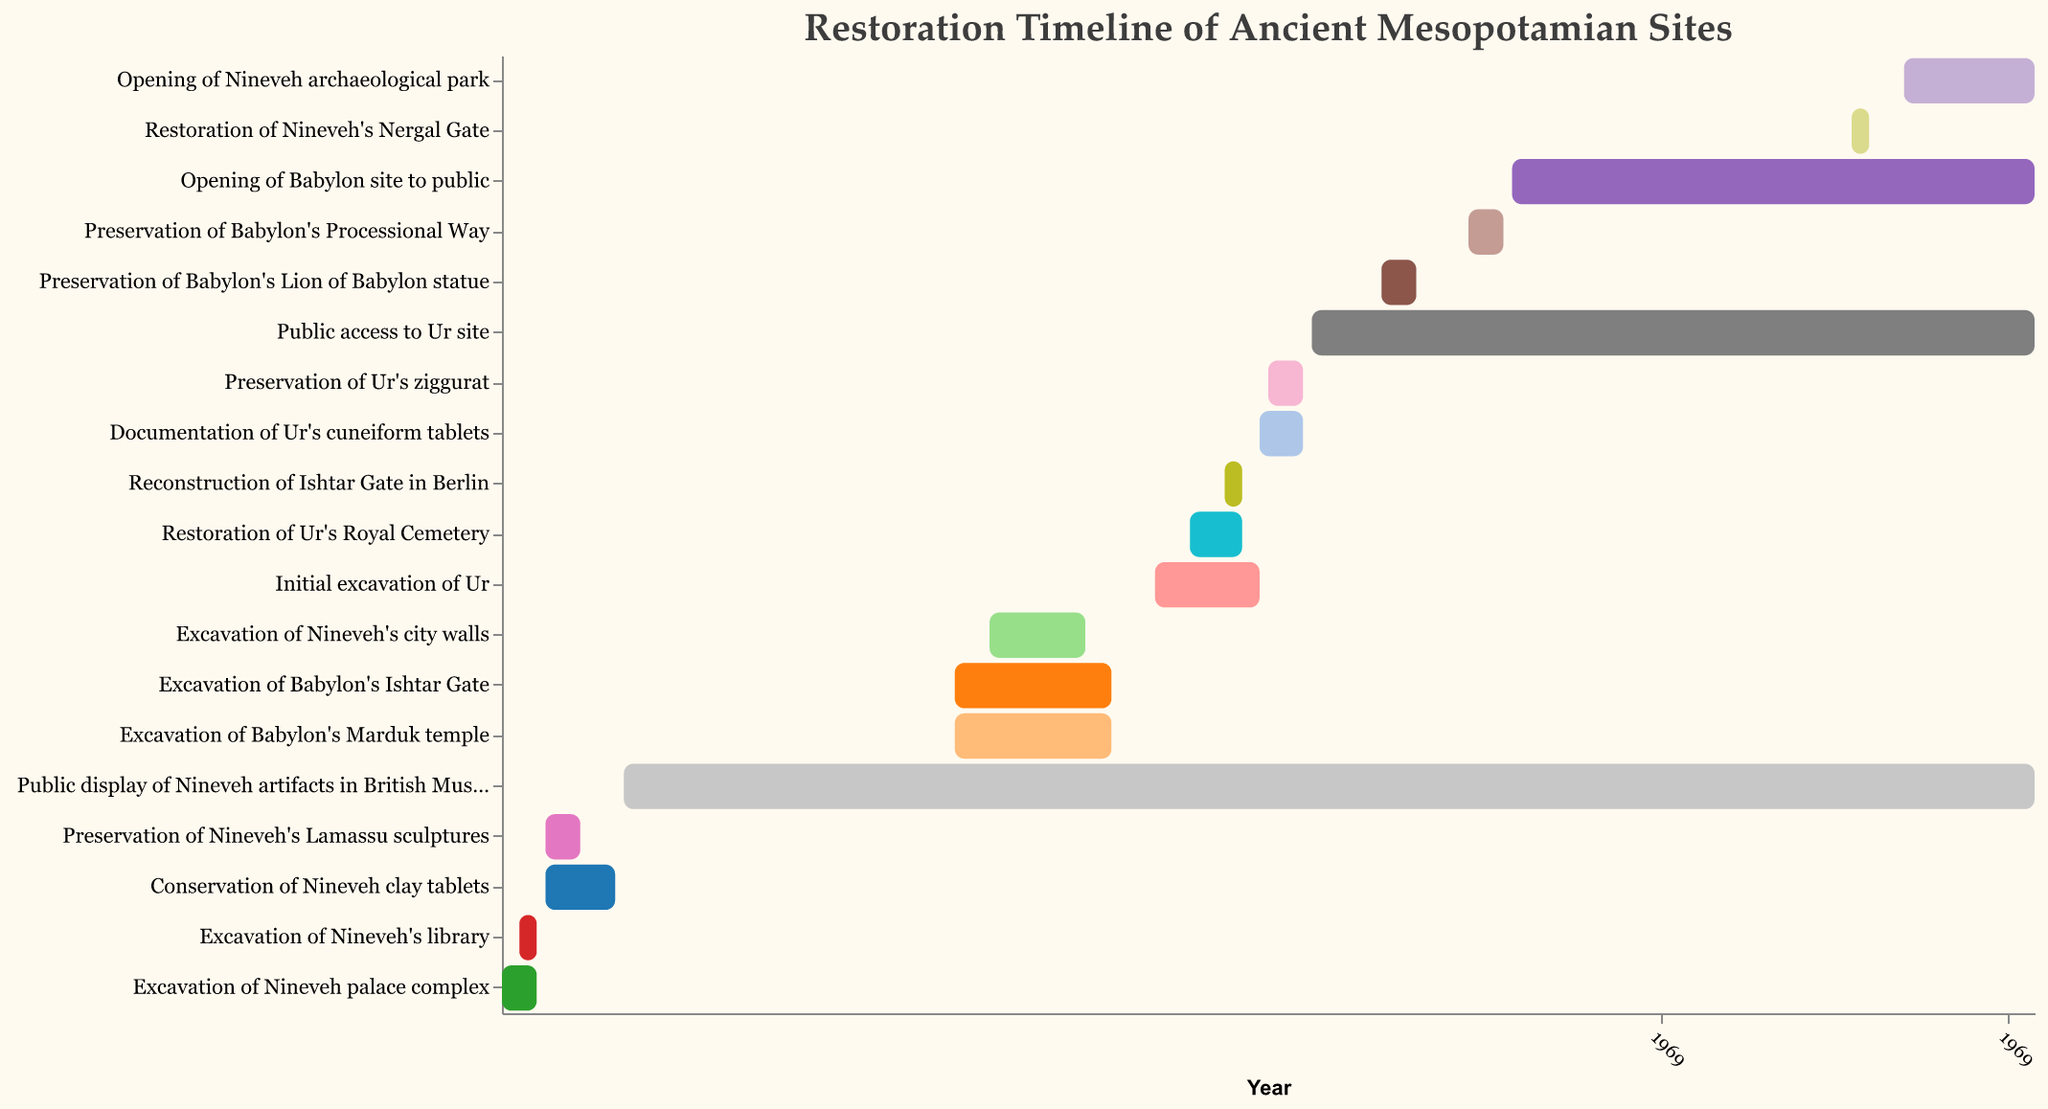What is the starting year of the Initial excavation of Ur? The starting year of the Initial excavation of Ur is shown on the horizontal axis next to the corresponding bar for this task. Look for "Initial excavation of Ur" on the vertical axis, then check the start of the bar on the horizontal time axis.
Answer: 1922 Which Mesopotamian site had its public display artifacts in a museum for the longest period? Find the tasks related to public display and find the end year of these tasks. Calculate the durations and identify which has the longest period.
Answer: Nineveh During which years did the Excavation of Nineveh's city walls take place? Locate the task "Excavation of Nineveh's city walls" on the vertical axis, and then check the start and end years of the corresponding bar on the horizontal time axis.
Answer: 1903-1914 Which task had an overlapping period with the preservation of Nineveh's Lamassu sculptures? Identify the timeline for the preservation of Nineveh's Lamassu sculptures (1852-1856) and see which other tasks occurred within this period.
Answer: Conservation of Nineveh clay tablets How many tasks were completed between 1930 and 1940? Evaluate the start and end dates of each task to see how many started, ended, or were in progress during 1930 to 1940. Count these tasks.
Answer: 5 Which task related to Babylon started first? Find the earliest starting year among the tasks associated with Babylon by comparing the start years.
Answer: Excavation of Babylon's Ishtar Gate What is the duration of the public access to Ur site? Find the start and end year for the "Public access to Ur site" task and calculate the difference between the end year and the start year.
Answer: 83 years How does the duration of Excavation of Nineveh palace complex compare to the excavation of Nineveh's library? Identify the start and end years for both tasks, calculate their durations, then compare the two durations.
Answer: Both are 3 years Which site had restoration tasks completed most recently? Find the tasks with the most recent end year by checking the horizontal axis and noting which site they belong to.
Answer: Nineveh What was the purpose of the task that started at 1949 and ended at 1951 in Nineveh? Locate the timeline from 1949 to 1951 and find the corresponding task from Nineveh by referring to the vertical axis.
Answer: Excavation of Nineveh's library 